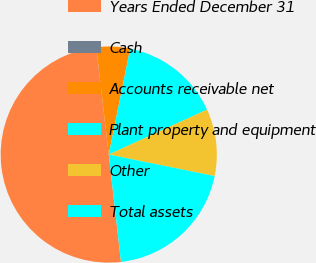Convert chart to OTSL. <chart><loc_0><loc_0><loc_500><loc_500><pie_chart><fcel>Years Ended December 31<fcel>Cash<fcel>Accounts receivable net<fcel>Plant property and equipment<fcel>Other<fcel>Total assets<nl><fcel>49.95%<fcel>0.02%<fcel>5.02%<fcel>15.0%<fcel>10.01%<fcel>20.0%<nl></chart> 